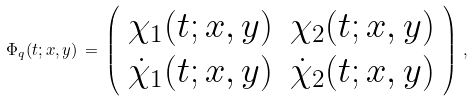<formula> <loc_0><loc_0><loc_500><loc_500>\Phi _ { q } ( t ; x , y ) \, = \, \left ( \begin{array} { c c } \chi _ { 1 } ( t ; x , y ) & \chi _ { 2 } ( t ; x , y ) \\ { \dot { \chi } _ { 1 } ( t ; x , y ) } & { \dot { \chi } _ { 2 } ( t ; x , y ) } \end{array} \right ) \, ,</formula> 